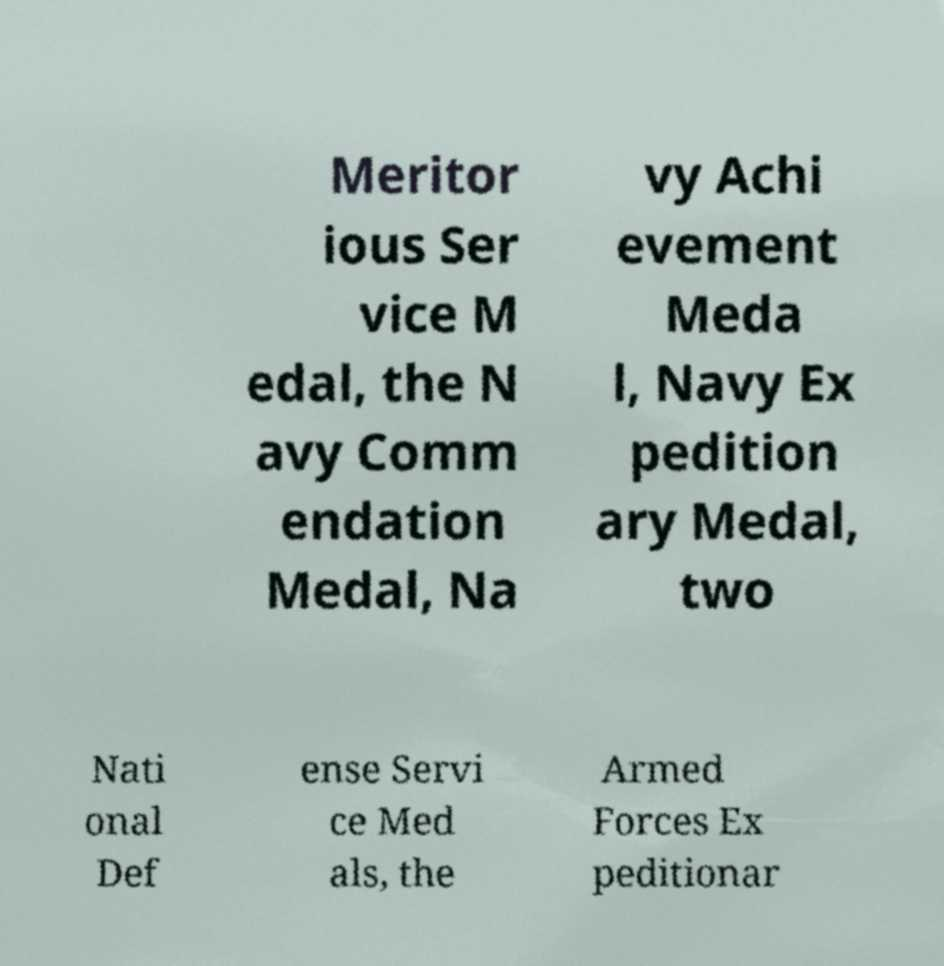Can you read and provide the text displayed in the image?This photo seems to have some interesting text. Can you extract and type it out for me? Meritor ious Ser vice M edal, the N avy Comm endation Medal, Na vy Achi evement Meda l, Navy Ex pedition ary Medal, two Nati onal Def ense Servi ce Med als, the Armed Forces Ex peditionar 